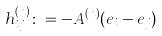<formula> <loc_0><loc_0><loc_500><loc_500>h ^ { ( n ) } _ { i j } \colon = - A ^ { ( n ) } ( e _ { i } - e _ { j } )</formula> 